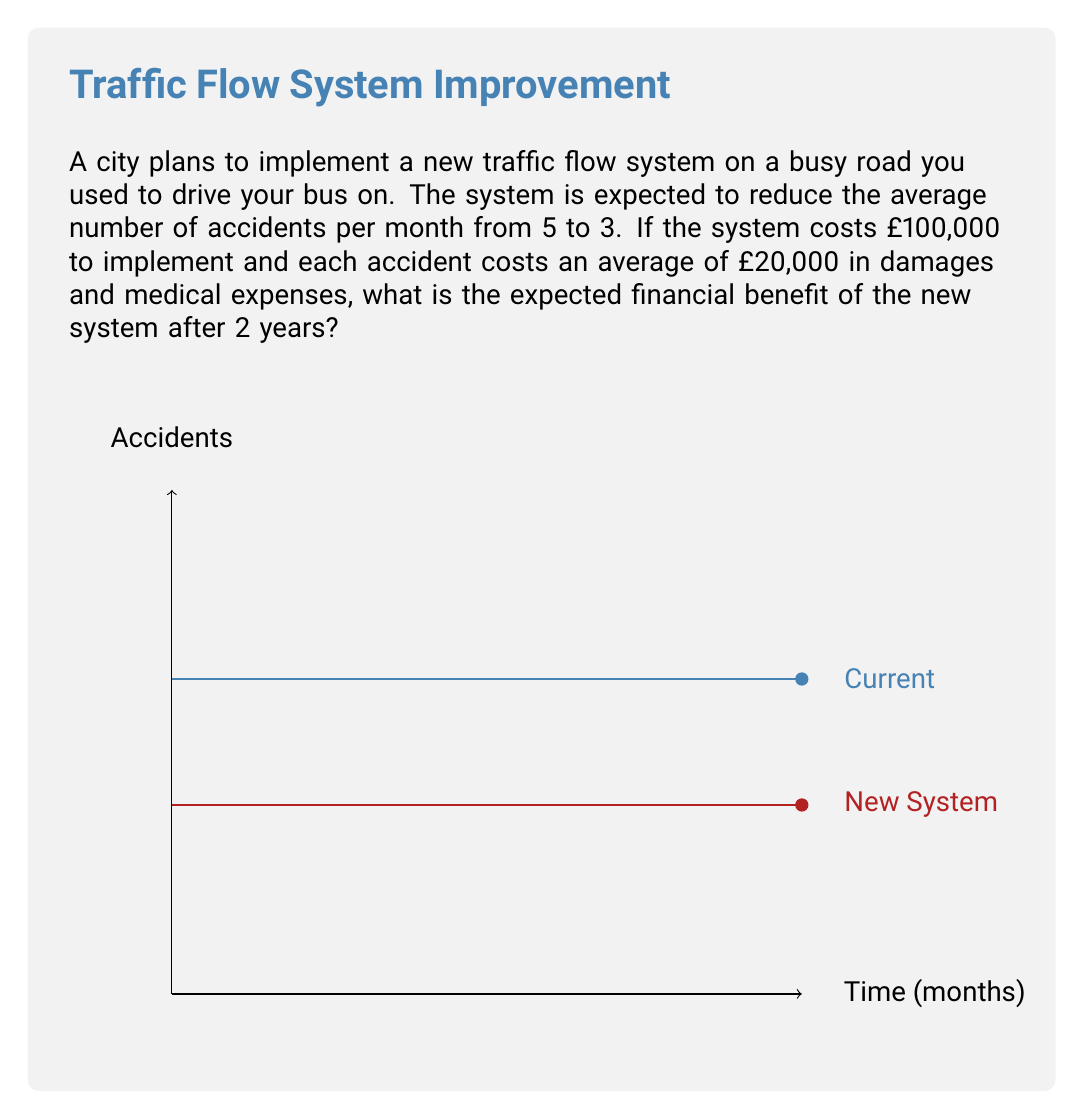Can you answer this question? Let's break this down step-by-step:

1) First, let's calculate the reduction in accidents per month:
   $5 - 3 = 2$ accidents reduced per month

2) Now, let's calculate the cost savings per month:
   $2 \text{ accidents} \times £20,000 = £40,000$ saved per month

3) Over 2 years (24 months), the total savings would be:
   $£40,000 \times 24 \text{ months} = £960,000$

4) However, we need to subtract the cost of implementing the system:
   $£960,000 - £100,000 = £860,000$

5) Therefore, the expected financial benefit after 2 years is £860,000.

To express this as an expected value calculation:

Let $X$ be the random variable representing the financial benefit after 2 years.

$$E[X] = E[\text{Savings}] - \text{Cost}$$
$$E[X] = (24 \times 2 \times £20,000) - £100,000 = £860,000$$

This calculation assumes a constant rate of accident reduction over the 2-year period.
Answer: £860,000 